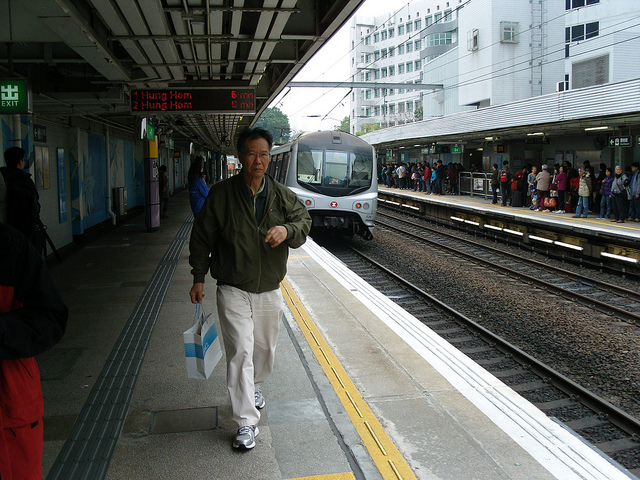Please extract the text content from this image. HUNG EXIT Hom 